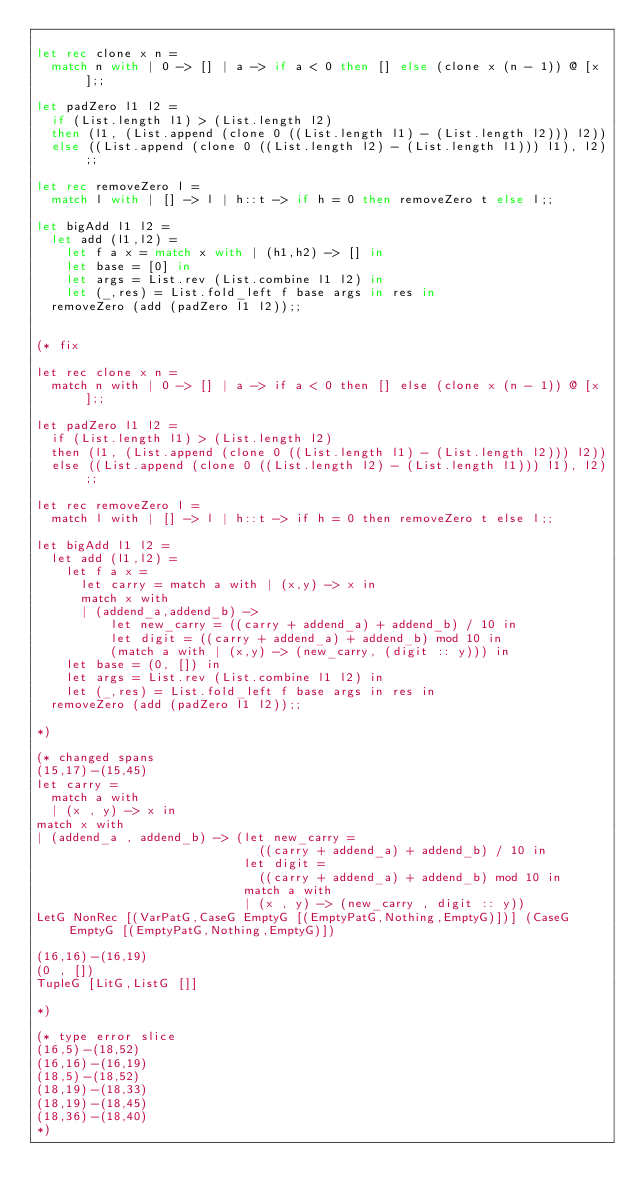Convert code to text. <code><loc_0><loc_0><loc_500><loc_500><_OCaml_>
let rec clone x n =
  match n with | 0 -> [] | a -> if a < 0 then [] else (clone x (n - 1)) @ [x];;

let padZero l1 l2 =
  if (List.length l1) > (List.length l2)
  then (l1, (List.append (clone 0 ((List.length l1) - (List.length l2))) l2))
  else ((List.append (clone 0 ((List.length l2) - (List.length l1))) l1), l2);;

let rec removeZero l =
  match l with | [] -> l | h::t -> if h = 0 then removeZero t else l;;

let bigAdd l1 l2 =
  let add (l1,l2) =
    let f a x = match x with | (h1,h2) -> [] in
    let base = [0] in
    let args = List.rev (List.combine l1 l2) in
    let (_,res) = List.fold_left f base args in res in
  removeZero (add (padZero l1 l2));;


(* fix

let rec clone x n =
  match n with | 0 -> [] | a -> if a < 0 then [] else (clone x (n - 1)) @ [x];;

let padZero l1 l2 =
  if (List.length l1) > (List.length l2)
  then (l1, (List.append (clone 0 ((List.length l1) - (List.length l2))) l2))
  else ((List.append (clone 0 ((List.length l2) - (List.length l1))) l1), l2);;

let rec removeZero l =
  match l with | [] -> l | h::t -> if h = 0 then removeZero t else l;;

let bigAdd l1 l2 =
  let add (l1,l2) =
    let f a x =
      let carry = match a with | (x,y) -> x in
      match x with
      | (addend_a,addend_b) ->
          let new_carry = ((carry + addend_a) + addend_b) / 10 in
          let digit = ((carry + addend_a) + addend_b) mod 10 in
          (match a with | (x,y) -> (new_carry, (digit :: y))) in
    let base = (0, []) in
    let args = List.rev (List.combine l1 l2) in
    let (_,res) = List.fold_left f base args in res in
  removeZero (add (padZero l1 l2));;

*)

(* changed spans
(15,17)-(15,45)
let carry =
  match a with
  | (x , y) -> x in
match x with
| (addend_a , addend_b) -> (let new_carry =
                              ((carry + addend_a) + addend_b) / 10 in
                            let digit =
                              ((carry + addend_a) + addend_b) mod 10 in
                            match a with
                            | (x , y) -> (new_carry , digit :: y))
LetG NonRec [(VarPatG,CaseG EmptyG [(EmptyPatG,Nothing,EmptyG)])] (CaseG EmptyG [(EmptyPatG,Nothing,EmptyG)])

(16,16)-(16,19)
(0 , [])
TupleG [LitG,ListG []]

*)

(* type error slice
(16,5)-(18,52)
(16,16)-(16,19)
(18,5)-(18,52)
(18,19)-(18,33)
(18,19)-(18,45)
(18,36)-(18,40)
*)
</code> 